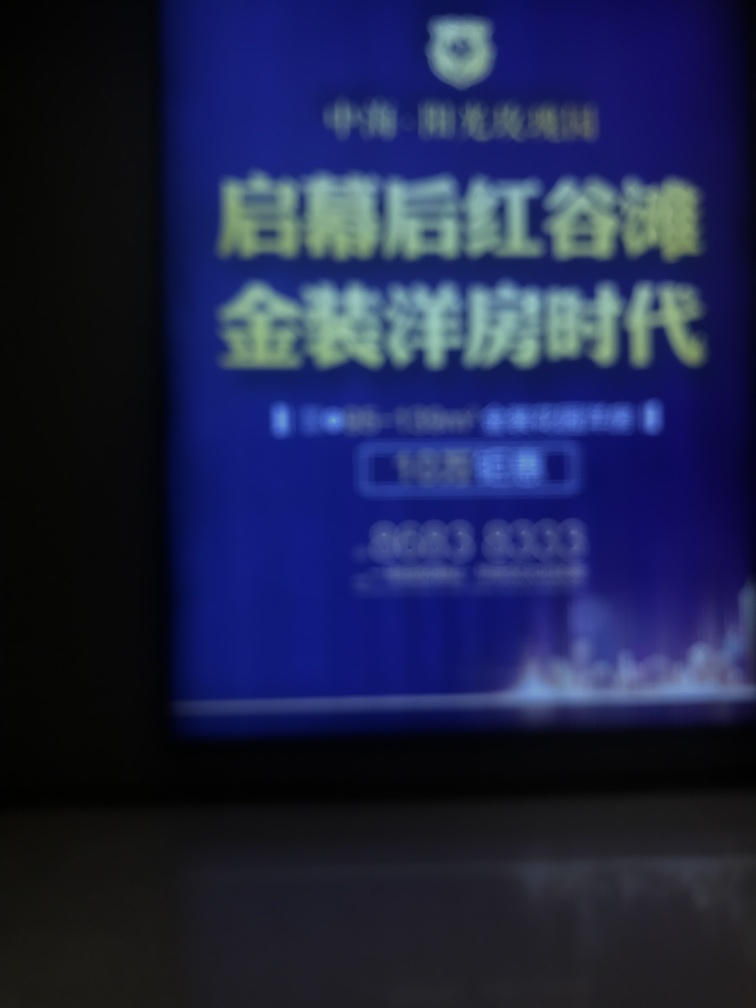Is the image clear? The image is blurry, and the text or details are not visible. A clear photo is needed to provide any meaningful analysis or description. 